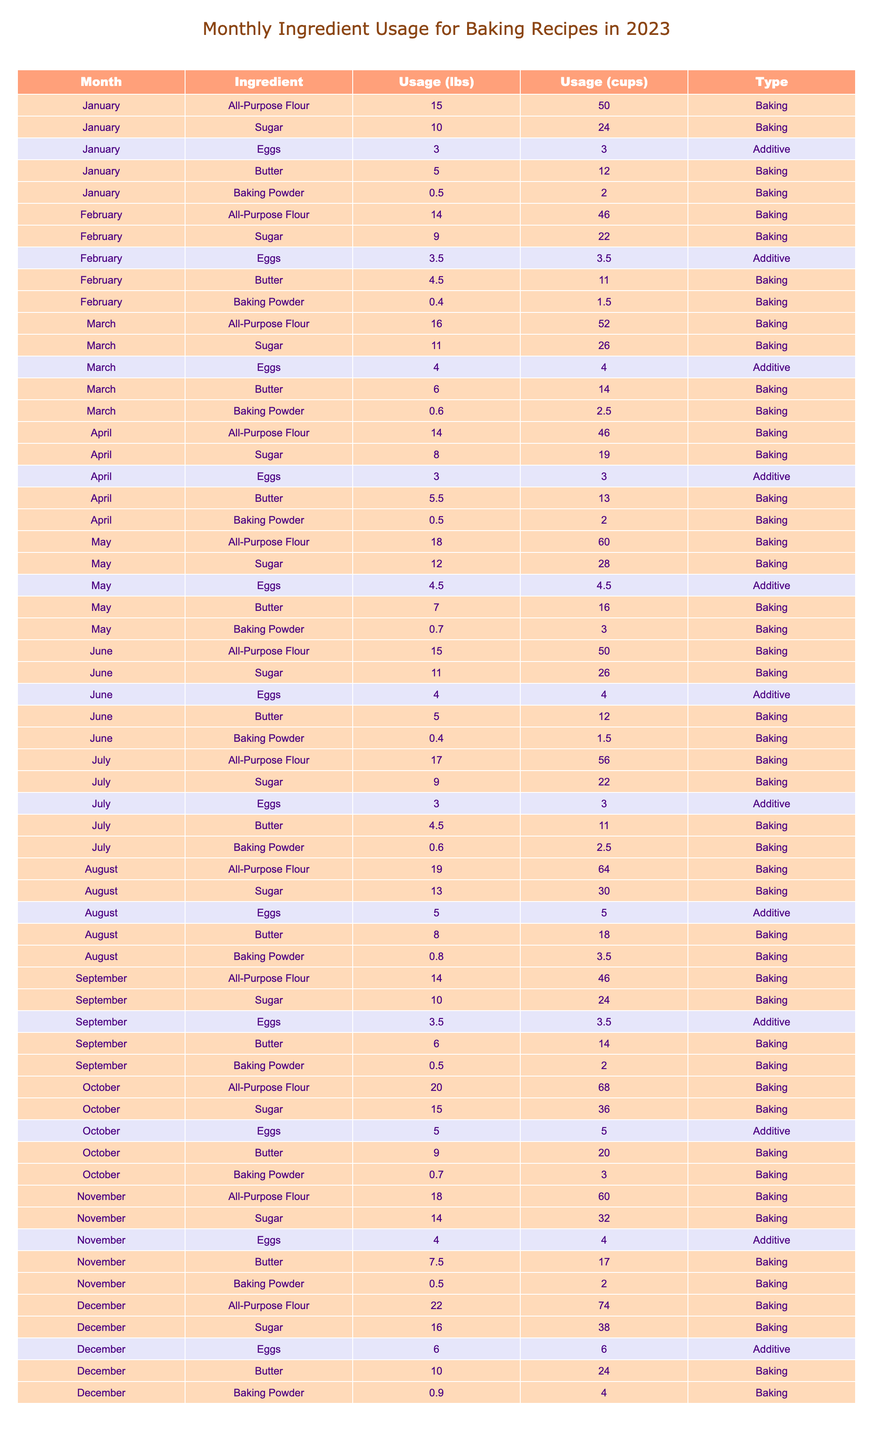What is the total usage of all-purpose flour in December? The table shows the usage of all-purpose flour in December, which is provided directly as 22 lbs.
Answer: 22 lbs Which month used the most sugar for baking? By comparing the sugar usage across all months, October has the highest usage at 15 lbs.
Answer: October How many eggs were used in total from January to March? The egg usage for January is 3 lbs, February is 3.5 lbs, and March is 4 lbs. Summing these values gives 3 + 3.5 + 4 = 10.5 lbs.
Answer: 10.5 lbs Was there a decrease in the quantity of baking powder used from March to April? In March, the baking powder usage is 0.6 lbs, and in April, it is 0.5 lbs. Since 0.6 is greater than 0.5, there was a decrease.
Answer: Yes What is the average amount of sugar used each month in 2023? The sugar usage for each month is: 10, 9, 11, 8, 12, 11, 9, 13, 10, 15, 14, and 16 (total 12 months). The sum is 10 + 9 + 11 + 8 + 12 + 11 + 9 + 13 + 10 + 15 + 14 + 16 =  10 + 9 + 11 + 8 + 12 + 11 + 9 + 13 + 10 + 15 + 14 + 16 =  14 + 11 + 16 =  166. Dividing this sum by 12 gives an average of 166/12 = 13.83.
Answer: 13.83 lbs How much all-purpose flour was used in July compared to June? In July, the usage of all-purpose flour was 17 lbs, while in June it was 15 lbs. The difference is 17 - 15 = 2 lbs more in July.
Answer: 2 lbs more in July Was the total usage of butter in October greater than or equal to 9 lbs? The butter usage in October is 9 lbs. Since the value is equal to 9, the answer is yes.
Answer: Yes In which month was the least amount of baking powder used? By inspecting the table, the lowest usage of baking powder is in February, with 0.4 lbs used.
Answer: February What is the total weight of all ingredients used in March? The total ingredient usage in March is as follows: All-Purpose Flour: 16 lbs, Sugar: 11 lbs, Eggs: 4 lbs, Butter: 6 lbs, Baking Powder: 0.6 lbs. Adding these gives 16 + 11 + 4 + 6 + 0.6 = 37.6 lbs.
Answer: 37.6 lbs How many pounds more sugar was used in December compared to January? The sugar usage in December is 16 lbs and in January is 10 lbs. The difference is 16 - 10 = 6 lbs more in December.
Answer: 6 lbs more What is the total butter usage from May to August? Butter usage for May is 7 lbs, June is 5 lbs, July is 4.5 lbs, and August is 8 lbs. Summing these gives 7 + 5 + 4.5 + 8 = 24.5 lbs.
Answer: 24.5 lbs 